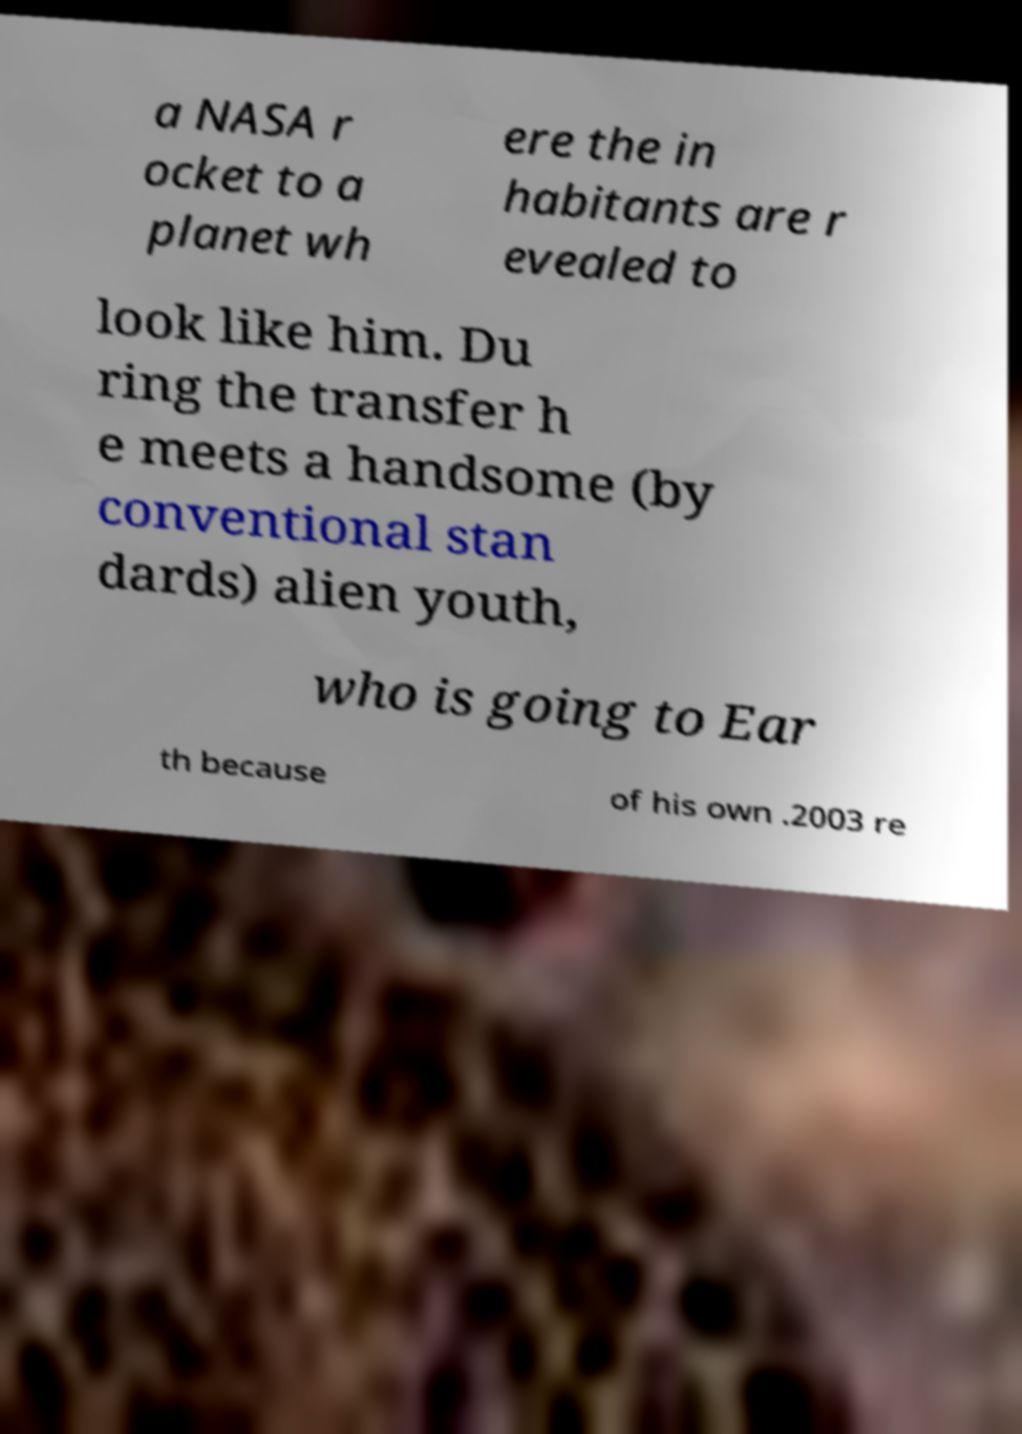Could you extract and type out the text from this image? a NASA r ocket to a planet wh ere the in habitants are r evealed to look like him. Du ring the transfer h e meets a handsome (by conventional stan dards) alien youth, who is going to Ear th because of his own .2003 re 